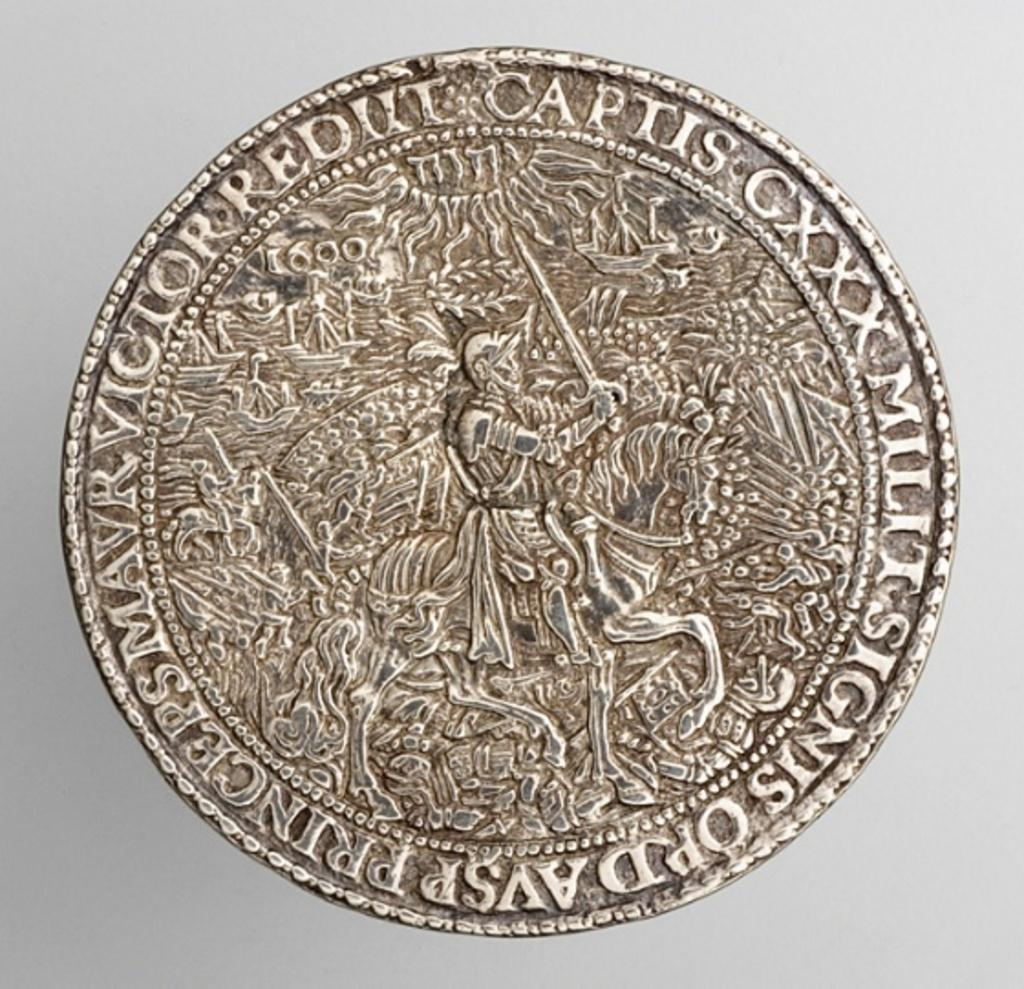<image>
Present a compact description of the photo's key features. A silver coin bears latin words including Captis CXXX. 